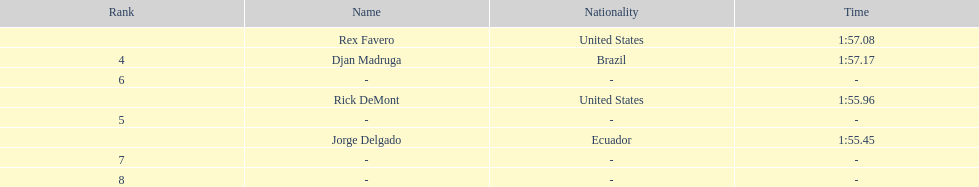Who was the last finisher from the us? Rex Favero. 